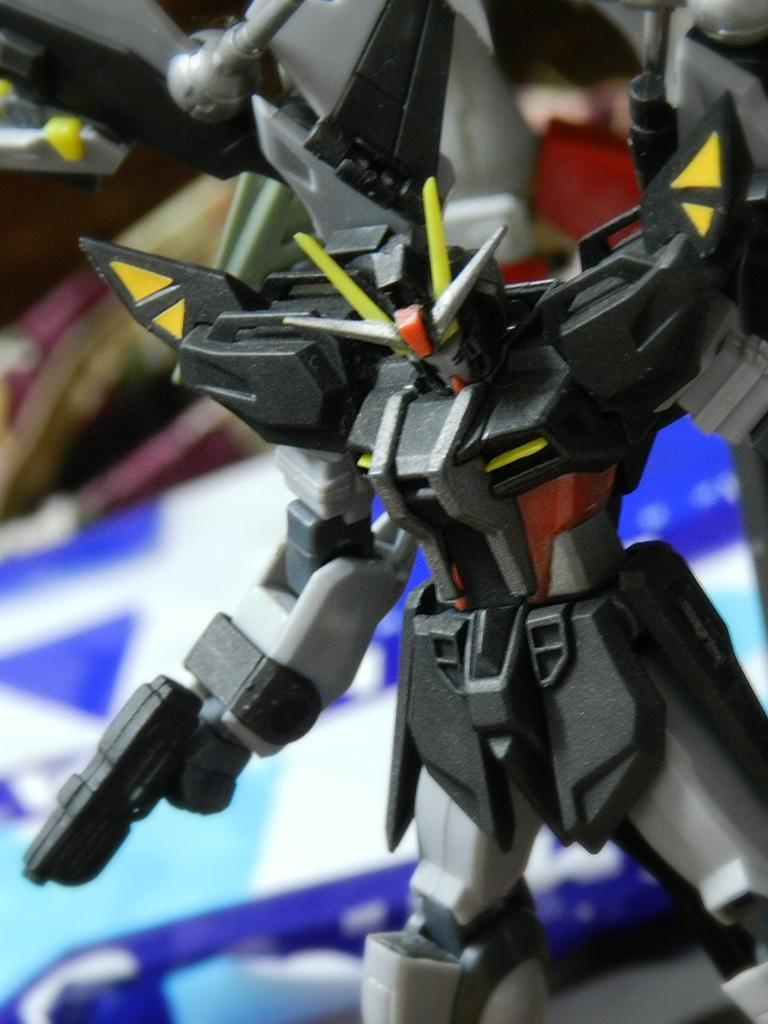What is the main subject of the image? There is a toy in the image. Can you describe the colors of the toy? The toy has yellow, grey, red, and black colors. What can be seen in the background of the image? There are blurred objects in the background of the image. What colors are present in the blurred objects? The blurred objects have blue, white, black, and yellow colors. Where is the cannon located in the image? There is no cannon present in the image. What type of rod is being used to stir the toy in the image? There is no rod or stirring action depicted in the image; it only shows a toy with various colors. 